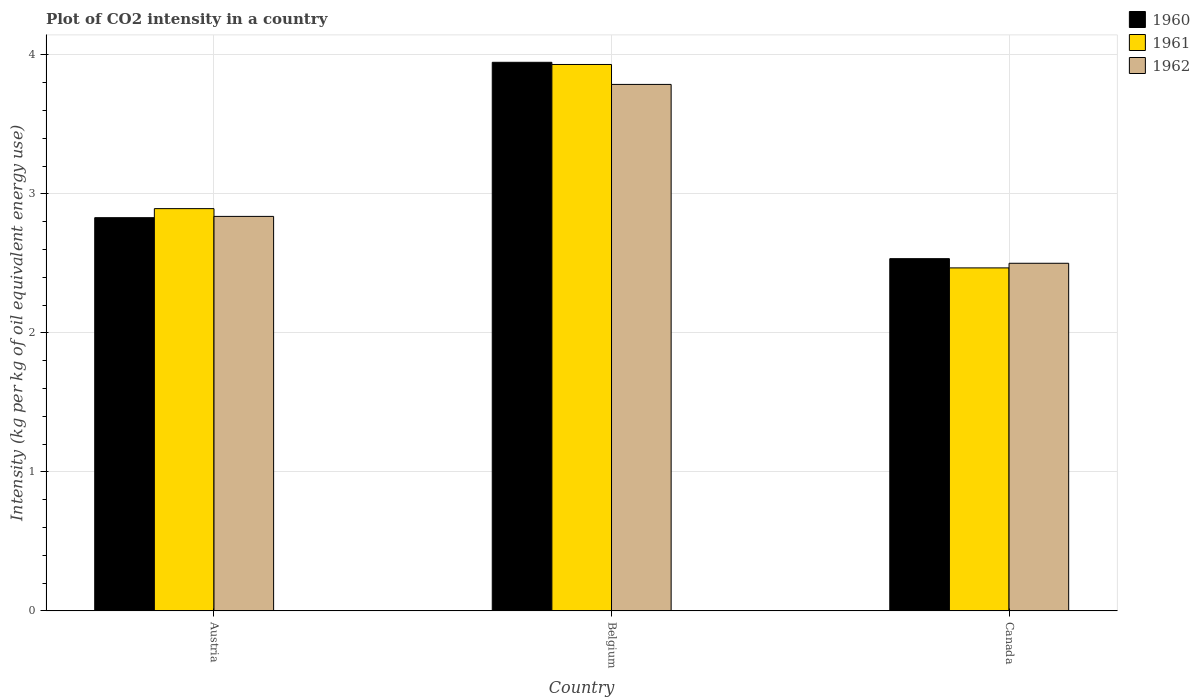How many groups of bars are there?
Your response must be concise. 3. Are the number of bars on each tick of the X-axis equal?
Ensure brevity in your answer.  Yes. How many bars are there on the 1st tick from the right?
Provide a short and direct response. 3. In how many cases, is the number of bars for a given country not equal to the number of legend labels?
Your answer should be very brief. 0. What is the CO2 intensity in in 1961 in Austria?
Give a very brief answer. 2.89. Across all countries, what is the maximum CO2 intensity in in 1961?
Provide a short and direct response. 3.93. Across all countries, what is the minimum CO2 intensity in in 1960?
Your response must be concise. 2.53. In which country was the CO2 intensity in in 1960 maximum?
Provide a succinct answer. Belgium. What is the total CO2 intensity in in 1961 in the graph?
Make the answer very short. 9.29. What is the difference between the CO2 intensity in in 1962 in Austria and that in Canada?
Provide a short and direct response. 0.34. What is the difference between the CO2 intensity in in 1962 in Austria and the CO2 intensity in in 1961 in Belgium?
Provide a short and direct response. -1.09. What is the average CO2 intensity in in 1961 per country?
Your answer should be compact. 3.1. What is the difference between the CO2 intensity in of/in 1960 and CO2 intensity in of/in 1961 in Austria?
Your answer should be compact. -0.07. What is the ratio of the CO2 intensity in in 1960 in Austria to that in Belgium?
Make the answer very short. 0.72. Is the difference between the CO2 intensity in in 1960 in Austria and Canada greater than the difference between the CO2 intensity in in 1961 in Austria and Canada?
Your answer should be very brief. No. What is the difference between the highest and the second highest CO2 intensity in in 1960?
Keep it short and to the point. -0.29. What is the difference between the highest and the lowest CO2 intensity in in 1962?
Offer a terse response. 1.29. In how many countries, is the CO2 intensity in in 1960 greater than the average CO2 intensity in in 1960 taken over all countries?
Make the answer very short. 1. Is the sum of the CO2 intensity in in 1961 in Belgium and Canada greater than the maximum CO2 intensity in in 1960 across all countries?
Your answer should be very brief. Yes. What does the 2nd bar from the left in Canada represents?
Your answer should be compact. 1961. Is it the case that in every country, the sum of the CO2 intensity in in 1962 and CO2 intensity in in 1960 is greater than the CO2 intensity in in 1961?
Provide a succinct answer. Yes. How many bars are there?
Offer a terse response. 9. What is the difference between two consecutive major ticks on the Y-axis?
Offer a very short reply. 1. Are the values on the major ticks of Y-axis written in scientific E-notation?
Ensure brevity in your answer.  No. Does the graph contain any zero values?
Keep it short and to the point. No. What is the title of the graph?
Offer a very short reply. Plot of CO2 intensity in a country. Does "1972" appear as one of the legend labels in the graph?
Give a very brief answer. No. What is the label or title of the Y-axis?
Your answer should be very brief. Intensity (kg per kg of oil equivalent energy use). What is the Intensity (kg per kg of oil equivalent energy use) of 1960 in Austria?
Your answer should be compact. 2.83. What is the Intensity (kg per kg of oil equivalent energy use) of 1961 in Austria?
Provide a succinct answer. 2.89. What is the Intensity (kg per kg of oil equivalent energy use) in 1962 in Austria?
Offer a very short reply. 2.84. What is the Intensity (kg per kg of oil equivalent energy use) of 1960 in Belgium?
Make the answer very short. 3.95. What is the Intensity (kg per kg of oil equivalent energy use) in 1961 in Belgium?
Keep it short and to the point. 3.93. What is the Intensity (kg per kg of oil equivalent energy use) in 1962 in Belgium?
Your response must be concise. 3.79. What is the Intensity (kg per kg of oil equivalent energy use) in 1960 in Canada?
Your answer should be compact. 2.53. What is the Intensity (kg per kg of oil equivalent energy use) of 1961 in Canada?
Offer a terse response. 2.47. What is the Intensity (kg per kg of oil equivalent energy use) of 1962 in Canada?
Keep it short and to the point. 2.5. Across all countries, what is the maximum Intensity (kg per kg of oil equivalent energy use) in 1960?
Give a very brief answer. 3.95. Across all countries, what is the maximum Intensity (kg per kg of oil equivalent energy use) of 1961?
Provide a short and direct response. 3.93. Across all countries, what is the maximum Intensity (kg per kg of oil equivalent energy use) of 1962?
Your response must be concise. 3.79. Across all countries, what is the minimum Intensity (kg per kg of oil equivalent energy use) of 1960?
Your answer should be very brief. 2.53. Across all countries, what is the minimum Intensity (kg per kg of oil equivalent energy use) of 1961?
Provide a short and direct response. 2.47. Across all countries, what is the minimum Intensity (kg per kg of oil equivalent energy use) of 1962?
Provide a succinct answer. 2.5. What is the total Intensity (kg per kg of oil equivalent energy use) of 1960 in the graph?
Ensure brevity in your answer.  9.31. What is the total Intensity (kg per kg of oil equivalent energy use) in 1961 in the graph?
Provide a short and direct response. 9.29. What is the total Intensity (kg per kg of oil equivalent energy use) of 1962 in the graph?
Your answer should be compact. 9.12. What is the difference between the Intensity (kg per kg of oil equivalent energy use) in 1960 in Austria and that in Belgium?
Give a very brief answer. -1.12. What is the difference between the Intensity (kg per kg of oil equivalent energy use) in 1961 in Austria and that in Belgium?
Provide a succinct answer. -1.04. What is the difference between the Intensity (kg per kg of oil equivalent energy use) of 1962 in Austria and that in Belgium?
Give a very brief answer. -0.95. What is the difference between the Intensity (kg per kg of oil equivalent energy use) in 1960 in Austria and that in Canada?
Give a very brief answer. 0.29. What is the difference between the Intensity (kg per kg of oil equivalent energy use) of 1961 in Austria and that in Canada?
Provide a succinct answer. 0.43. What is the difference between the Intensity (kg per kg of oil equivalent energy use) in 1962 in Austria and that in Canada?
Your response must be concise. 0.34. What is the difference between the Intensity (kg per kg of oil equivalent energy use) of 1960 in Belgium and that in Canada?
Your response must be concise. 1.41. What is the difference between the Intensity (kg per kg of oil equivalent energy use) of 1961 in Belgium and that in Canada?
Offer a very short reply. 1.46. What is the difference between the Intensity (kg per kg of oil equivalent energy use) in 1962 in Belgium and that in Canada?
Provide a short and direct response. 1.29. What is the difference between the Intensity (kg per kg of oil equivalent energy use) in 1960 in Austria and the Intensity (kg per kg of oil equivalent energy use) in 1961 in Belgium?
Give a very brief answer. -1.1. What is the difference between the Intensity (kg per kg of oil equivalent energy use) of 1960 in Austria and the Intensity (kg per kg of oil equivalent energy use) of 1962 in Belgium?
Offer a very short reply. -0.96. What is the difference between the Intensity (kg per kg of oil equivalent energy use) in 1961 in Austria and the Intensity (kg per kg of oil equivalent energy use) in 1962 in Belgium?
Make the answer very short. -0.89. What is the difference between the Intensity (kg per kg of oil equivalent energy use) in 1960 in Austria and the Intensity (kg per kg of oil equivalent energy use) in 1961 in Canada?
Make the answer very short. 0.36. What is the difference between the Intensity (kg per kg of oil equivalent energy use) in 1960 in Austria and the Intensity (kg per kg of oil equivalent energy use) in 1962 in Canada?
Your answer should be compact. 0.33. What is the difference between the Intensity (kg per kg of oil equivalent energy use) of 1961 in Austria and the Intensity (kg per kg of oil equivalent energy use) of 1962 in Canada?
Your answer should be compact. 0.39. What is the difference between the Intensity (kg per kg of oil equivalent energy use) of 1960 in Belgium and the Intensity (kg per kg of oil equivalent energy use) of 1961 in Canada?
Offer a very short reply. 1.48. What is the difference between the Intensity (kg per kg of oil equivalent energy use) of 1960 in Belgium and the Intensity (kg per kg of oil equivalent energy use) of 1962 in Canada?
Your answer should be compact. 1.45. What is the difference between the Intensity (kg per kg of oil equivalent energy use) of 1961 in Belgium and the Intensity (kg per kg of oil equivalent energy use) of 1962 in Canada?
Offer a terse response. 1.43. What is the average Intensity (kg per kg of oil equivalent energy use) in 1960 per country?
Keep it short and to the point. 3.1. What is the average Intensity (kg per kg of oil equivalent energy use) in 1961 per country?
Give a very brief answer. 3.1. What is the average Intensity (kg per kg of oil equivalent energy use) in 1962 per country?
Make the answer very short. 3.04. What is the difference between the Intensity (kg per kg of oil equivalent energy use) of 1960 and Intensity (kg per kg of oil equivalent energy use) of 1961 in Austria?
Offer a terse response. -0.07. What is the difference between the Intensity (kg per kg of oil equivalent energy use) in 1960 and Intensity (kg per kg of oil equivalent energy use) in 1962 in Austria?
Your response must be concise. -0.01. What is the difference between the Intensity (kg per kg of oil equivalent energy use) in 1961 and Intensity (kg per kg of oil equivalent energy use) in 1962 in Austria?
Offer a terse response. 0.06. What is the difference between the Intensity (kg per kg of oil equivalent energy use) in 1960 and Intensity (kg per kg of oil equivalent energy use) in 1961 in Belgium?
Make the answer very short. 0.02. What is the difference between the Intensity (kg per kg of oil equivalent energy use) in 1960 and Intensity (kg per kg of oil equivalent energy use) in 1962 in Belgium?
Keep it short and to the point. 0.16. What is the difference between the Intensity (kg per kg of oil equivalent energy use) of 1961 and Intensity (kg per kg of oil equivalent energy use) of 1962 in Belgium?
Your answer should be very brief. 0.14. What is the difference between the Intensity (kg per kg of oil equivalent energy use) of 1960 and Intensity (kg per kg of oil equivalent energy use) of 1961 in Canada?
Provide a short and direct response. 0.07. What is the difference between the Intensity (kg per kg of oil equivalent energy use) of 1960 and Intensity (kg per kg of oil equivalent energy use) of 1962 in Canada?
Your response must be concise. 0.03. What is the difference between the Intensity (kg per kg of oil equivalent energy use) in 1961 and Intensity (kg per kg of oil equivalent energy use) in 1962 in Canada?
Make the answer very short. -0.03. What is the ratio of the Intensity (kg per kg of oil equivalent energy use) in 1960 in Austria to that in Belgium?
Your answer should be very brief. 0.72. What is the ratio of the Intensity (kg per kg of oil equivalent energy use) of 1961 in Austria to that in Belgium?
Provide a succinct answer. 0.74. What is the ratio of the Intensity (kg per kg of oil equivalent energy use) in 1962 in Austria to that in Belgium?
Provide a short and direct response. 0.75. What is the ratio of the Intensity (kg per kg of oil equivalent energy use) of 1960 in Austria to that in Canada?
Give a very brief answer. 1.12. What is the ratio of the Intensity (kg per kg of oil equivalent energy use) in 1961 in Austria to that in Canada?
Give a very brief answer. 1.17. What is the ratio of the Intensity (kg per kg of oil equivalent energy use) in 1962 in Austria to that in Canada?
Provide a short and direct response. 1.13. What is the ratio of the Intensity (kg per kg of oil equivalent energy use) in 1960 in Belgium to that in Canada?
Offer a very short reply. 1.56. What is the ratio of the Intensity (kg per kg of oil equivalent energy use) in 1961 in Belgium to that in Canada?
Your response must be concise. 1.59. What is the ratio of the Intensity (kg per kg of oil equivalent energy use) of 1962 in Belgium to that in Canada?
Your response must be concise. 1.51. What is the difference between the highest and the second highest Intensity (kg per kg of oil equivalent energy use) in 1960?
Your response must be concise. 1.12. What is the difference between the highest and the second highest Intensity (kg per kg of oil equivalent energy use) in 1961?
Your response must be concise. 1.04. What is the difference between the highest and the second highest Intensity (kg per kg of oil equivalent energy use) in 1962?
Ensure brevity in your answer.  0.95. What is the difference between the highest and the lowest Intensity (kg per kg of oil equivalent energy use) in 1960?
Ensure brevity in your answer.  1.41. What is the difference between the highest and the lowest Intensity (kg per kg of oil equivalent energy use) in 1961?
Your answer should be compact. 1.46. What is the difference between the highest and the lowest Intensity (kg per kg of oil equivalent energy use) of 1962?
Keep it short and to the point. 1.29. 